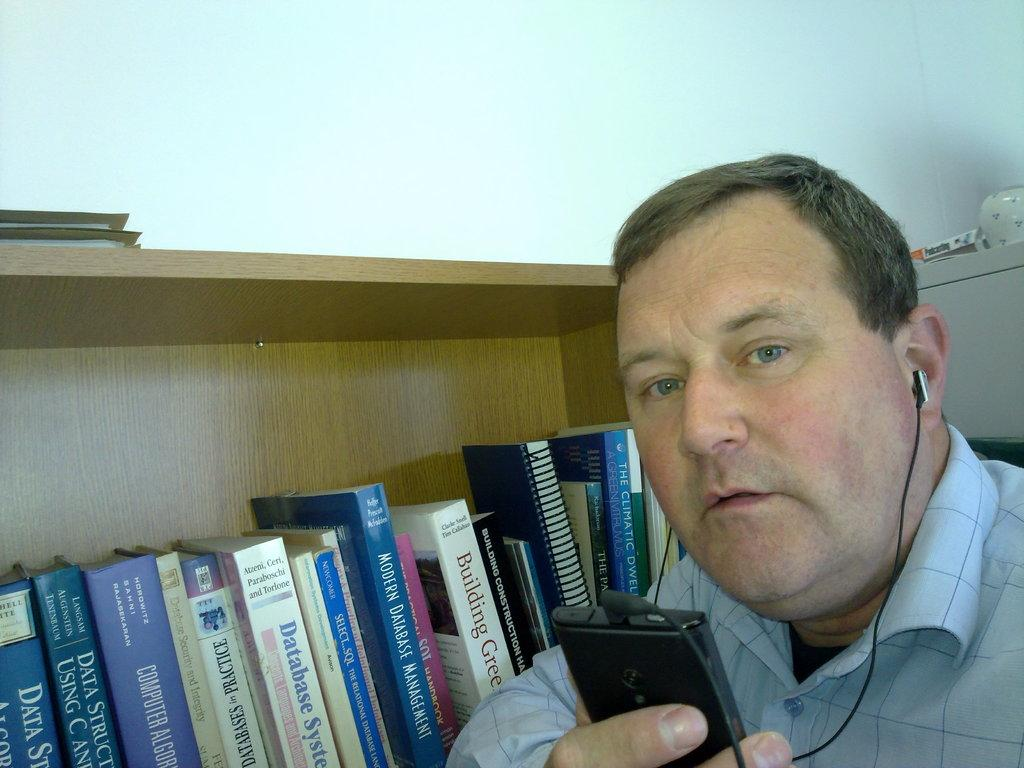<image>
Relay a brief, clear account of the picture shown. A man stands in front of a bookshelf next to a Database System book listening to a tape 